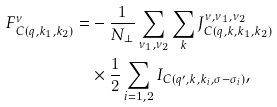Convert formula to latex. <formula><loc_0><loc_0><loc_500><loc_500>F ^ { \nu } _ { C ( q , k _ { 1 } , k _ { 2 } ) } = & - \frac { 1 } { N _ { \perp } } \sum _ { \nu _ { 1 } , \nu _ { 2 } } \sum _ { k } J ^ { \nu , \nu _ { 1 } , \nu _ { 2 } } _ { C ( q , k , k _ { 1 } , k _ { 2 } ) } \\ & \times \frac { 1 } { 2 } \sum _ { i = 1 , 2 } { I } _ { C ( q ^ { \prime } , k , k _ { i } , \sigma - \sigma _ { i } ) } ,</formula> 